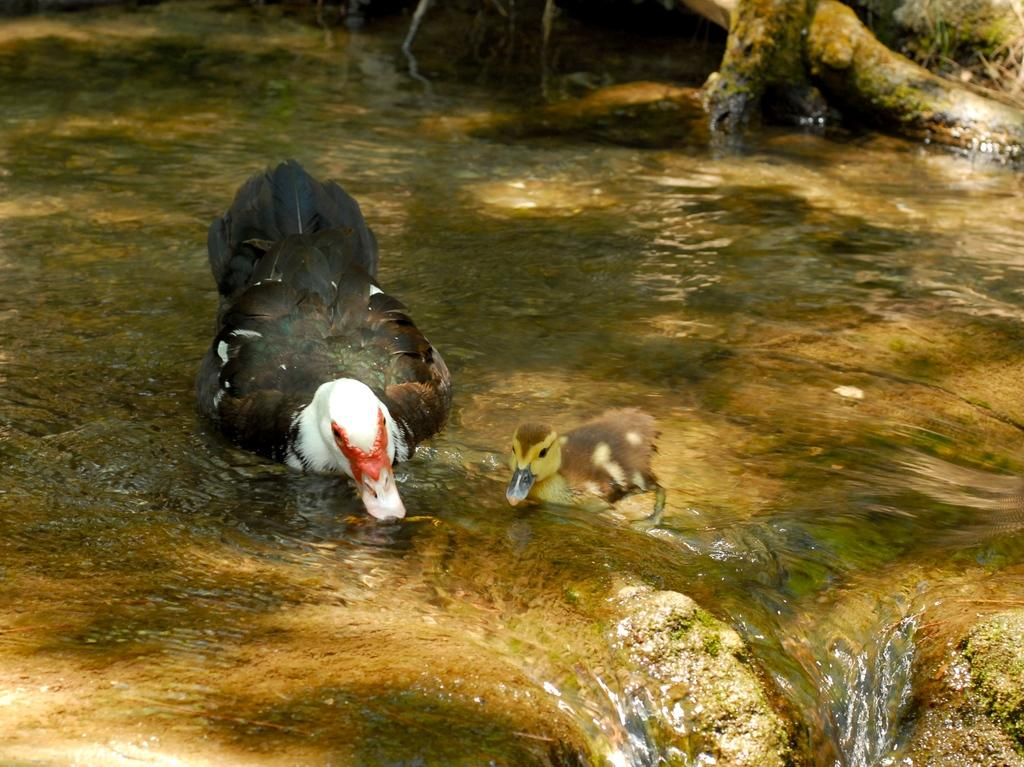What type of animals can be seen in the image? Birds can be seen in the water in the image. What material is visible in the image? There is some wood visible in the image. What type of vegetation can be seen in the image? There is grass in the image. What type of discussion is taking place between the birds in the image? There is no indication of a discussion between the birds in the image, as they are simply swimming in the water. 